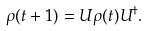<formula> <loc_0><loc_0><loc_500><loc_500>\rho ( t + 1 ) = U \rho ( t ) U ^ { \dagger } .</formula> 